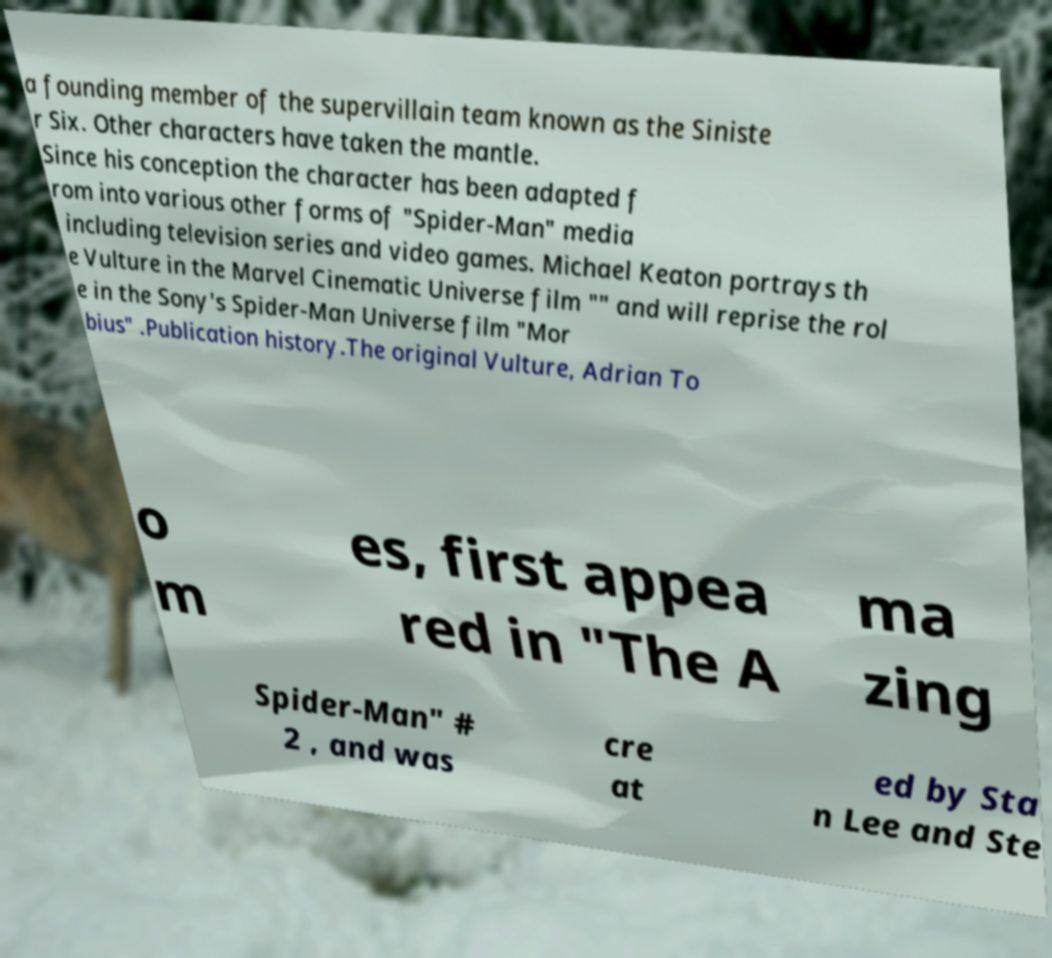Could you assist in decoding the text presented in this image and type it out clearly? a founding member of the supervillain team known as the Siniste r Six. Other characters have taken the mantle. Since his conception the character has been adapted f rom into various other forms of "Spider-Man" media including television series and video games. Michael Keaton portrays th e Vulture in the Marvel Cinematic Universe film "" and will reprise the rol e in the Sony's Spider-Man Universe film "Mor bius" .Publication history.The original Vulture, Adrian To o m es, first appea red in "The A ma zing Spider-Man" # 2 , and was cre at ed by Sta n Lee and Ste 